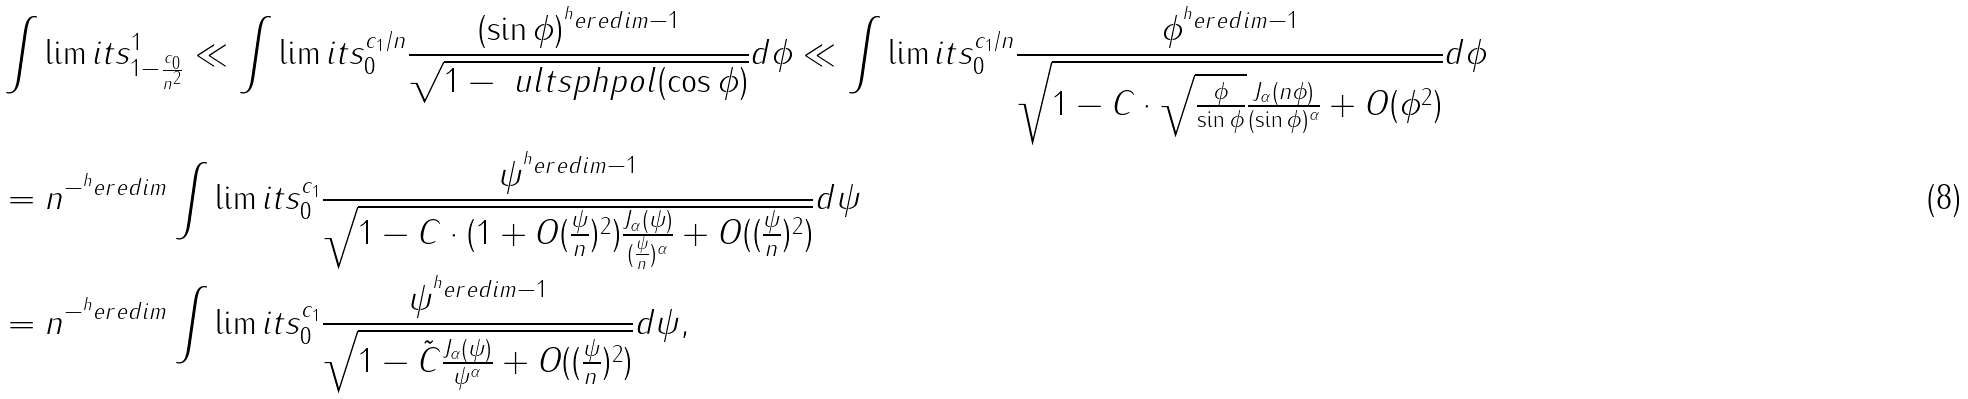Convert formula to latex. <formula><loc_0><loc_0><loc_500><loc_500>& \int \lim i t s _ { 1 - \frac { c _ { 0 } } { n ^ { 2 } } } ^ { 1 } \ll \int \lim i t s _ { 0 } ^ { c _ { 1 } / n } \frac { ( \sin { \phi } ) ^ { ^ { h } e r e d i m - 1 } } { \sqrt { 1 - \ u l t s p h p o l ( \cos { \phi } ) } } d \phi \ll \int \lim i t s _ { 0 } ^ { c _ { 1 } / n } \frac { \phi ^ { ^ { h } e r e d i m - 1 } } { \sqrt { 1 - C \cdot \sqrt { \frac { \phi } { \sin { \phi } } } \frac { J _ { \alpha } ( n \phi ) } { ( \sin { \phi } ) ^ { \alpha } } + O ( \phi ^ { 2 } ) } } d \phi \\ & = n ^ { - ^ { h } e r e d i m } \int \lim i t s _ { 0 } ^ { c _ { 1 } } \frac { \psi ^ { ^ { h } e r e d i m - 1 } } { \sqrt { 1 - C \cdot ( 1 + O ( \frac { \psi } { n } ) ^ { 2 } ) \frac { J _ { \alpha } ( \psi ) } { ( \frac { \psi } { n } ) ^ { \alpha } } + O ( ( \frac { \psi } { n } ) ^ { 2 } ) } } d \psi \\ & = n ^ { - ^ { h } e r e d i m } \int \lim i t s _ { 0 } ^ { c _ { 1 } } \frac { \psi ^ { ^ { h } e r e d i m - 1 } } { \sqrt { 1 - \tilde { C } \frac { J _ { \alpha } ( \psi ) } { \psi ^ { \alpha } } + O ( ( \frac { \psi } { n } ) ^ { 2 } ) } } d \psi ,</formula> 